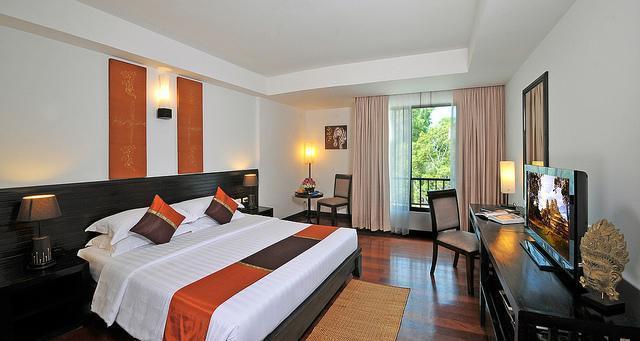How many lamps are in this room?
Give a very brief answer. 4. How many beds?
Give a very brief answer. 1. How many pillows are there?
Give a very brief answer. 6. How many chairs are there?
Give a very brief answer. 1. 